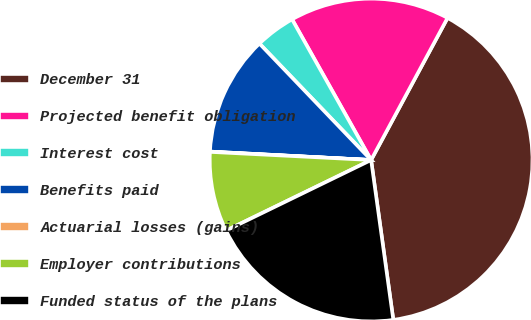Convert chart. <chart><loc_0><loc_0><loc_500><loc_500><pie_chart><fcel>December 31<fcel>Projected benefit obligation<fcel>Interest cost<fcel>Benefits paid<fcel>Actuarial losses (gains)<fcel>Employer contributions<fcel>Funded status of the plans<nl><fcel>39.95%<fcel>16.0%<fcel>4.02%<fcel>12.0%<fcel>0.03%<fcel>8.01%<fcel>19.99%<nl></chart> 